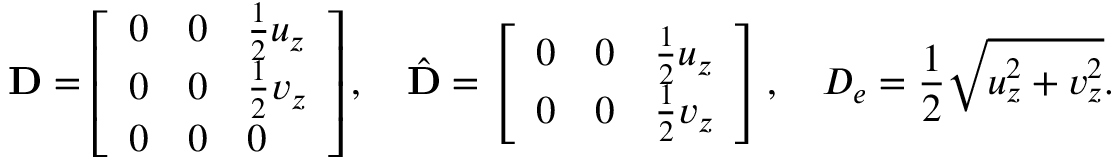<formula> <loc_0><loc_0><loc_500><loc_500>D = \left [ \begin{array} { l l l } { 0 } & { 0 } & { \frac { 1 } { 2 } u _ { z } } \\ { 0 } & { 0 } & { \frac { 1 } { 2 } v _ { z } } \\ { 0 } & { 0 } & { 0 } \end{array} \right ] , \quad \hat { D } = \left [ \begin{array} { l l l } { 0 } & { 0 } & { \frac { 1 } { 2 } u _ { z } } \\ { 0 } & { 0 } & { \frac { 1 } { 2 } v _ { z } } \end{array} \right ] , \quad D _ { e } = \frac { 1 } { 2 } \sqrt { u _ { z } ^ { 2 } + v _ { z } ^ { 2 } } .</formula> 